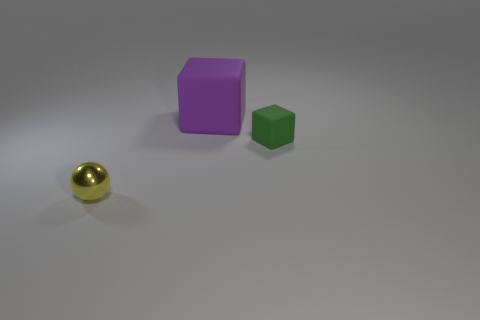Are there any other things that are the same size as the purple rubber thing?
Provide a short and direct response. No. Is there anything else that is made of the same material as the small yellow sphere?
Your answer should be very brief. No. There is a object that is in front of the green cube; does it have the same size as the purple matte thing?
Make the answer very short. No. What shape is the thing that is both in front of the purple matte thing and left of the tiny rubber block?
Your response must be concise. Sphere. There is a small metallic ball; are there any large things on the left side of it?
Your answer should be very brief. No. Is there any other thing that is the same shape as the small green object?
Your answer should be compact. Yes. Is the small yellow metallic thing the same shape as the big purple object?
Provide a succinct answer. No. Is the number of small objects left of the big object the same as the number of tiny green objects to the left of the green cube?
Your response must be concise. No. How many other things are made of the same material as the tiny green cube?
Provide a short and direct response. 1. How many large things are purple cylinders or purple blocks?
Ensure brevity in your answer.  1. 